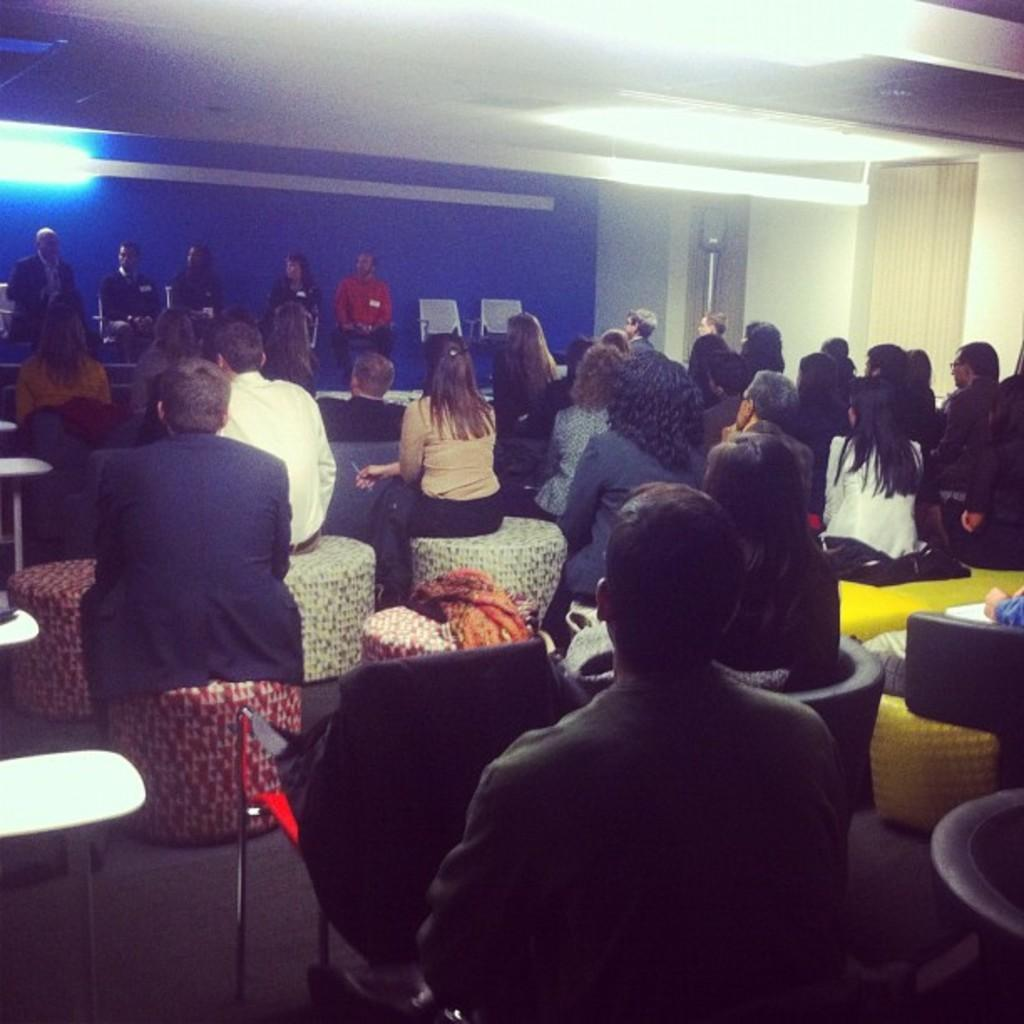What is the primary activity of the people in the image? The people in the image are sitting. What type of seating is available for the people? Some people are sitting on chairs. What color is the wall visible in the image? The wall visible in the image is blue. How many snakes are slithering on the blue wall in the image? There are no snakes present in the image; the wall is blue, but there are no snakes visible. 